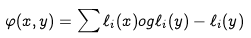<formula> <loc_0><loc_0><loc_500><loc_500>\varphi ( x , y ) = \sum \ell _ { i } ( x ) \L o g \ell _ { i } ( y ) - \ell _ { i } ( y )</formula> 